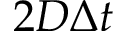<formula> <loc_0><loc_0><loc_500><loc_500>2 D \Delta t</formula> 